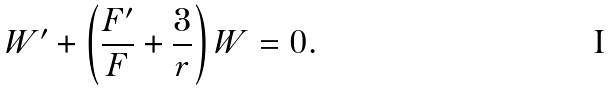Convert formula to latex. <formula><loc_0><loc_0><loc_500><loc_500>W ^ { \prime } + \left ( \frac { F ^ { \prime } } { F } + \frac { 3 } { r } \right ) W = 0 .</formula> 